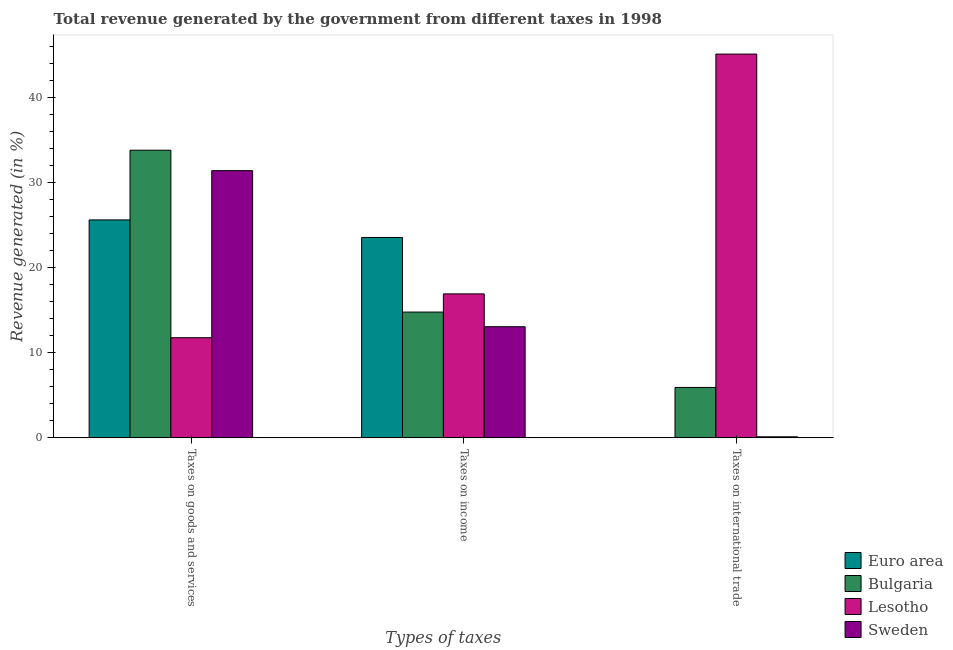How many different coloured bars are there?
Ensure brevity in your answer.  4. How many groups of bars are there?
Give a very brief answer. 3. Are the number of bars per tick equal to the number of legend labels?
Provide a succinct answer. Yes. What is the label of the 3rd group of bars from the left?
Make the answer very short. Taxes on international trade. What is the percentage of revenue generated by taxes on goods and services in Lesotho?
Keep it short and to the point. 11.78. Across all countries, what is the maximum percentage of revenue generated by taxes on income?
Ensure brevity in your answer.  23.56. Across all countries, what is the minimum percentage of revenue generated by taxes on income?
Provide a succinct answer. 13.07. In which country was the percentage of revenue generated by taxes on goods and services maximum?
Your response must be concise. Bulgaria. In which country was the percentage of revenue generated by tax on international trade minimum?
Your response must be concise. Euro area. What is the total percentage of revenue generated by taxes on income in the graph?
Keep it short and to the point. 68.35. What is the difference between the percentage of revenue generated by tax on international trade in Lesotho and that in Sweden?
Ensure brevity in your answer.  45. What is the difference between the percentage of revenue generated by tax on international trade in Euro area and the percentage of revenue generated by taxes on goods and services in Bulgaria?
Provide a succinct answer. -33.82. What is the average percentage of revenue generated by tax on international trade per country?
Your response must be concise. 12.8. What is the difference between the percentage of revenue generated by taxes on goods and services and percentage of revenue generated by tax on international trade in Euro area?
Provide a short and direct response. 25.62. In how many countries, is the percentage of revenue generated by taxes on goods and services greater than 28 %?
Your answer should be compact. 2. What is the ratio of the percentage of revenue generated by taxes on income in Bulgaria to that in Euro area?
Provide a short and direct response. 0.63. Is the percentage of revenue generated by tax on international trade in Lesotho less than that in Euro area?
Give a very brief answer. No. What is the difference between the highest and the second highest percentage of revenue generated by taxes on goods and services?
Ensure brevity in your answer.  2.4. What is the difference between the highest and the lowest percentage of revenue generated by taxes on goods and services?
Your answer should be very brief. 22.04. Is the sum of the percentage of revenue generated by tax on international trade in Euro area and Sweden greater than the maximum percentage of revenue generated by taxes on income across all countries?
Your answer should be compact. No. What does the 1st bar from the left in Taxes on goods and services represents?
Make the answer very short. Euro area. Is it the case that in every country, the sum of the percentage of revenue generated by taxes on goods and services and percentage of revenue generated by taxes on income is greater than the percentage of revenue generated by tax on international trade?
Make the answer very short. No. Are all the bars in the graph horizontal?
Your answer should be compact. No. What is the difference between two consecutive major ticks on the Y-axis?
Offer a terse response. 10. Does the graph contain any zero values?
Your response must be concise. No. How are the legend labels stacked?
Your answer should be very brief. Vertical. What is the title of the graph?
Offer a terse response. Total revenue generated by the government from different taxes in 1998. Does "Bahamas" appear as one of the legend labels in the graph?
Offer a very short reply. No. What is the label or title of the X-axis?
Your response must be concise. Types of taxes. What is the label or title of the Y-axis?
Provide a succinct answer. Revenue generated (in %). What is the Revenue generated (in %) of Euro area in Taxes on goods and services?
Offer a terse response. 25.63. What is the Revenue generated (in %) in Bulgaria in Taxes on goods and services?
Provide a short and direct response. 33.82. What is the Revenue generated (in %) in Lesotho in Taxes on goods and services?
Your response must be concise. 11.78. What is the Revenue generated (in %) of Sweden in Taxes on goods and services?
Your answer should be very brief. 31.42. What is the Revenue generated (in %) of Euro area in Taxes on income?
Offer a very short reply. 23.56. What is the Revenue generated (in %) in Bulgaria in Taxes on income?
Your response must be concise. 14.79. What is the Revenue generated (in %) of Lesotho in Taxes on income?
Provide a short and direct response. 16.93. What is the Revenue generated (in %) of Sweden in Taxes on income?
Keep it short and to the point. 13.07. What is the Revenue generated (in %) of Euro area in Taxes on international trade?
Ensure brevity in your answer.  0. What is the Revenue generated (in %) of Bulgaria in Taxes on international trade?
Offer a terse response. 5.93. What is the Revenue generated (in %) in Lesotho in Taxes on international trade?
Give a very brief answer. 45.12. What is the Revenue generated (in %) of Sweden in Taxes on international trade?
Your response must be concise. 0.13. Across all Types of taxes, what is the maximum Revenue generated (in %) in Euro area?
Offer a terse response. 25.63. Across all Types of taxes, what is the maximum Revenue generated (in %) in Bulgaria?
Make the answer very short. 33.82. Across all Types of taxes, what is the maximum Revenue generated (in %) of Lesotho?
Offer a very short reply. 45.12. Across all Types of taxes, what is the maximum Revenue generated (in %) in Sweden?
Make the answer very short. 31.42. Across all Types of taxes, what is the minimum Revenue generated (in %) in Euro area?
Provide a short and direct response. 0. Across all Types of taxes, what is the minimum Revenue generated (in %) in Bulgaria?
Your answer should be compact. 5.93. Across all Types of taxes, what is the minimum Revenue generated (in %) of Lesotho?
Your answer should be very brief. 11.78. Across all Types of taxes, what is the minimum Revenue generated (in %) of Sweden?
Make the answer very short. 0.13. What is the total Revenue generated (in %) in Euro area in the graph?
Offer a very short reply. 49.19. What is the total Revenue generated (in %) in Bulgaria in the graph?
Make the answer very short. 54.54. What is the total Revenue generated (in %) in Lesotho in the graph?
Your answer should be compact. 73.83. What is the total Revenue generated (in %) of Sweden in the graph?
Offer a very short reply. 44.61. What is the difference between the Revenue generated (in %) of Euro area in Taxes on goods and services and that in Taxes on income?
Provide a short and direct response. 2.06. What is the difference between the Revenue generated (in %) of Bulgaria in Taxes on goods and services and that in Taxes on income?
Ensure brevity in your answer.  19.03. What is the difference between the Revenue generated (in %) in Lesotho in Taxes on goods and services and that in Taxes on income?
Keep it short and to the point. -5.15. What is the difference between the Revenue generated (in %) in Sweden in Taxes on goods and services and that in Taxes on income?
Ensure brevity in your answer.  18.35. What is the difference between the Revenue generated (in %) of Euro area in Taxes on goods and services and that in Taxes on international trade?
Offer a very short reply. 25.62. What is the difference between the Revenue generated (in %) in Bulgaria in Taxes on goods and services and that in Taxes on international trade?
Keep it short and to the point. 27.89. What is the difference between the Revenue generated (in %) in Lesotho in Taxes on goods and services and that in Taxes on international trade?
Your response must be concise. -33.35. What is the difference between the Revenue generated (in %) in Sweden in Taxes on goods and services and that in Taxes on international trade?
Provide a short and direct response. 31.29. What is the difference between the Revenue generated (in %) in Euro area in Taxes on income and that in Taxes on international trade?
Ensure brevity in your answer.  23.56. What is the difference between the Revenue generated (in %) in Bulgaria in Taxes on income and that in Taxes on international trade?
Give a very brief answer. 8.86. What is the difference between the Revenue generated (in %) of Lesotho in Taxes on income and that in Taxes on international trade?
Make the answer very short. -28.2. What is the difference between the Revenue generated (in %) in Sweden in Taxes on income and that in Taxes on international trade?
Ensure brevity in your answer.  12.94. What is the difference between the Revenue generated (in %) in Euro area in Taxes on goods and services and the Revenue generated (in %) in Bulgaria in Taxes on income?
Your answer should be very brief. 10.83. What is the difference between the Revenue generated (in %) of Euro area in Taxes on goods and services and the Revenue generated (in %) of Lesotho in Taxes on income?
Give a very brief answer. 8.7. What is the difference between the Revenue generated (in %) of Euro area in Taxes on goods and services and the Revenue generated (in %) of Sweden in Taxes on income?
Offer a very short reply. 12.56. What is the difference between the Revenue generated (in %) in Bulgaria in Taxes on goods and services and the Revenue generated (in %) in Lesotho in Taxes on income?
Offer a terse response. 16.89. What is the difference between the Revenue generated (in %) of Bulgaria in Taxes on goods and services and the Revenue generated (in %) of Sweden in Taxes on income?
Give a very brief answer. 20.75. What is the difference between the Revenue generated (in %) in Lesotho in Taxes on goods and services and the Revenue generated (in %) in Sweden in Taxes on income?
Your answer should be compact. -1.29. What is the difference between the Revenue generated (in %) in Euro area in Taxes on goods and services and the Revenue generated (in %) in Bulgaria in Taxes on international trade?
Ensure brevity in your answer.  19.69. What is the difference between the Revenue generated (in %) of Euro area in Taxes on goods and services and the Revenue generated (in %) of Lesotho in Taxes on international trade?
Your answer should be compact. -19.5. What is the difference between the Revenue generated (in %) of Euro area in Taxes on goods and services and the Revenue generated (in %) of Sweden in Taxes on international trade?
Provide a short and direct response. 25.5. What is the difference between the Revenue generated (in %) in Bulgaria in Taxes on goods and services and the Revenue generated (in %) in Lesotho in Taxes on international trade?
Your answer should be very brief. -11.3. What is the difference between the Revenue generated (in %) of Bulgaria in Taxes on goods and services and the Revenue generated (in %) of Sweden in Taxes on international trade?
Provide a succinct answer. 33.7. What is the difference between the Revenue generated (in %) in Lesotho in Taxes on goods and services and the Revenue generated (in %) in Sweden in Taxes on international trade?
Offer a very short reply. 11.65. What is the difference between the Revenue generated (in %) of Euro area in Taxes on income and the Revenue generated (in %) of Bulgaria in Taxes on international trade?
Make the answer very short. 17.63. What is the difference between the Revenue generated (in %) in Euro area in Taxes on income and the Revenue generated (in %) in Lesotho in Taxes on international trade?
Provide a short and direct response. -21.56. What is the difference between the Revenue generated (in %) of Euro area in Taxes on income and the Revenue generated (in %) of Sweden in Taxes on international trade?
Your answer should be very brief. 23.44. What is the difference between the Revenue generated (in %) of Bulgaria in Taxes on income and the Revenue generated (in %) of Lesotho in Taxes on international trade?
Provide a short and direct response. -30.33. What is the difference between the Revenue generated (in %) in Bulgaria in Taxes on income and the Revenue generated (in %) in Sweden in Taxes on international trade?
Your answer should be compact. 14.66. What is the difference between the Revenue generated (in %) of Lesotho in Taxes on income and the Revenue generated (in %) of Sweden in Taxes on international trade?
Offer a terse response. 16.8. What is the average Revenue generated (in %) of Euro area per Types of taxes?
Ensure brevity in your answer.  16.4. What is the average Revenue generated (in %) of Bulgaria per Types of taxes?
Your response must be concise. 18.18. What is the average Revenue generated (in %) in Lesotho per Types of taxes?
Your answer should be very brief. 24.61. What is the average Revenue generated (in %) in Sweden per Types of taxes?
Your answer should be very brief. 14.87. What is the difference between the Revenue generated (in %) in Euro area and Revenue generated (in %) in Bulgaria in Taxes on goods and services?
Your answer should be compact. -8.2. What is the difference between the Revenue generated (in %) in Euro area and Revenue generated (in %) in Lesotho in Taxes on goods and services?
Your answer should be compact. 13.85. What is the difference between the Revenue generated (in %) in Euro area and Revenue generated (in %) in Sweden in Taxes on goods and services?
Offer a very short reply. -5.79. What is the difference between the Revenue generated (in %) in Bulgaria and Revenue generated (in %) in Lesotho in Taxes on goods and services?
Provide a short and direct response. 22.04. What is the difference between the Revenue generated (in %) of Bulgaria and Revenue generated (in %) of Sweden in Taxes on goods and services?
Your response must be concise. 2.4. What is the difference between the Revenue generated (in %) in Lesotho and Revenue generated (in %) in Sweden in Taxes on goods and services?
Make the answer very short. -19.64. What is the difference between the Revenue generated (in %) of Euro area and Revenue generated (in %) of Bulgaria in Taxes on income?
Your answer should be very brief. 8.77. What is the difference between the Revenue generated (in %) of Euro area and Revenue generated (in %) of Lesotho in Taxes on income?
Your answer should be compact. 6.63. What is the difference between the Revenue generated (in %) in Euro area and Revenue generated (in %) in Sweden in Taxes on income?
Make the answer very short. 10.49. What is the difference between the Revenue generated (in %) of Bulgaria and Revenue generated (in %) of Lesotho in Taxes on income?
Provide a succinct answer. -2.14. What is the difference between the Revenue generated (in %) in Bulgaria and Revenue generated (in %) in Sweden in Taxes on income?
Make the answer very short. 1.72. What is the difference between the Revenue generated (in %) in Lesotho and Revenue generated (in %) in Sweden in Taxes on income?
Offer a terse response. 3.86. What is the difference between the Revenue generated (in %) of Euro area and Revenue generated (in %) of Bulgaria in Taxes on international trade?
Offer a very short reply. -5.93. What is the difference between the Revenue generated (in %) of Euro area and Revenue generated (in %) of Lesotho in Taxes on international trade?
Your answer should be compact. -45.12. What is the difference between the Revenue generated (in %) in Euro area and Revenue generated (in %) in Sweden in Taxes on international trade?
Your answer should be very brief. -0.12. What is the difference between the Revenue generated (in %) in Bulgaria and Revenue generated (in %) in Lesotho in Taxes on international trade?
Keep it short and to the point. -39.19. What is the difference between the Revenue generated (in %) of Bulgaria and Revenue generated (in %) of Sweden in Taxes on international trade?
Provide a short and direct response. 5.81. What is the difference between the Revenue generated (in %) in Lesotho and Revenue generated (in %) in Sweden in Taxes on international trade?
Keep it short and to the point. 45. What is the ratio of the Revenue generated (in %) of Euro area in Taxes on goods and services to that in Taxes on income?
Give a very brief answer. 1.09. What is the ratio of the Revenue generated (in %) in Bulgaria in Taxes on goods and services to that in Taxes on income?
Offer a very short reply. 2.29. What is the ratio of the Revenue generated (in %) in Lesotho in Taxes on goods and services to that in Taxes on income?
Your answer should be compact. 0.7. What is the ratio of the Revenue generated (in %) of Sweden in Taxes on goods and services to that in Taxes on income?
Offer a very short reply. 2.4. What is the ratio of the Revenue generated (in %) of Euro area in Taxes on goods and services to that in Taxes on international trade?
Provide a succinct answer. 2.80e+04. What is the ratio of the Revenue generated (in %) in Bulgaria in Taxes on goods and services to that in Taxes on international trade?
Offer a very short reply. 5.7. What is the ratio of the Revenue generated (in %) of Lesotho in Taxes on goods and services to that in Taxes on international trade?
Make the answer very short. 0.26. What is the ratio of the Revenue generated (in %) in Sweden in Taxes on goods and services to that in Taxes on international trade?
Provide a succinct answer. 249.88. What is the ratio of the Revenue generated (in %) in Euro area in Taxes on income to that in Taxes on international trade?
Your response must be concise. 2.58e+04. What is the ratio of the Revenue generated (in %) in Bulgaria in Taxes on income to that in Taxes on international trade?
Keep it short and to the point. 2.49. What is the ratio of the Revenue generated (in %) in Lesotho in Taxes on income to that in Taxes on international trade?
Your answer should be compact. 0.38. What is the ratio of the Revenue generated (in %) in Sweden in Taxes on income to that in Taxes on international trade?
Give a very brief answer. 103.93. What is the difference between the highest and the second highest Revenue generated (in %) in Euro area?
Ensure brevity in your answer.  2.06. What is the difference between the highest and the second highest Revenue generated (in %) of Bulgaria?
Your response must be concise. 19.03. What is the difference between the highest and the second highest Revenue generated (in %) in Lesotho?
Make the answer very short. 28.2. What is the difference between the highest and the second highest Revenue generated (in %) of Sweden?
Your answer should be compact. 18.35. What is the difference between the highest and the lowest Revenue generated (in %) in Euro area?
Provide a succinct answer. 25.62. What is the difference between the highest and the lowest Revenue generated (in %) in Bulgaria?
Ensure brevity in your answer.  27.89. What is the difference between the highest and the lowest Revenue generated (in %) in Lesotho?
Your answer should be very brief. 33.35. What is the difference between the highest and the lowest Revenue generated (in %) in Sweden?
Ensure brevity in your answer.  31.29. 